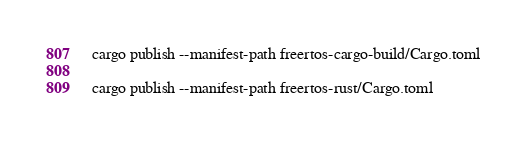Convert code to text. <code><loc_0><loc_0><loc_500><loc_500><_Bash_>cargo publish --manifest-path freertos-cargo-build/Cargo.toml

cargo publish --manifest-path freertos-rust/Cargo.toml</code> 